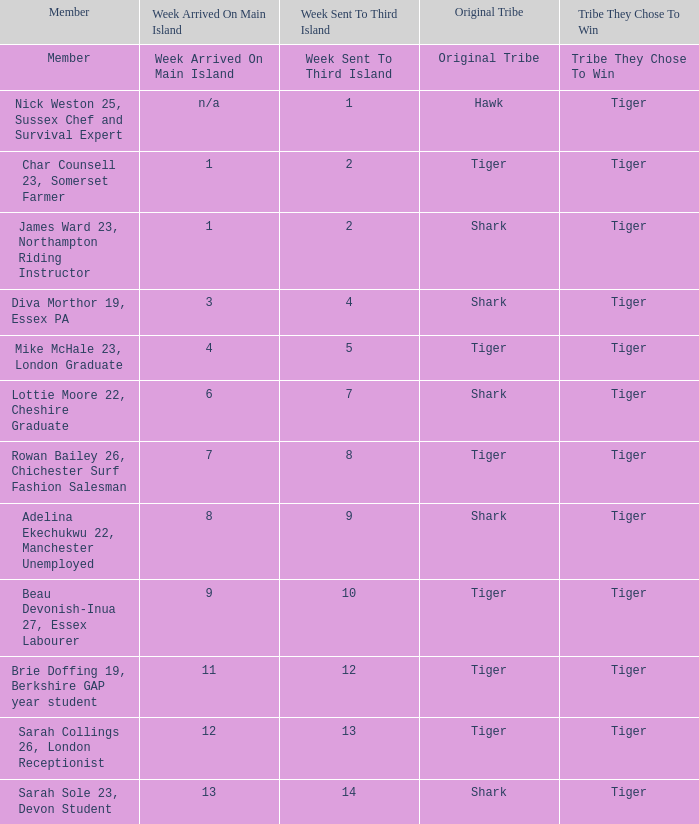How many members arrived on the main island in week 4? 1.0. 